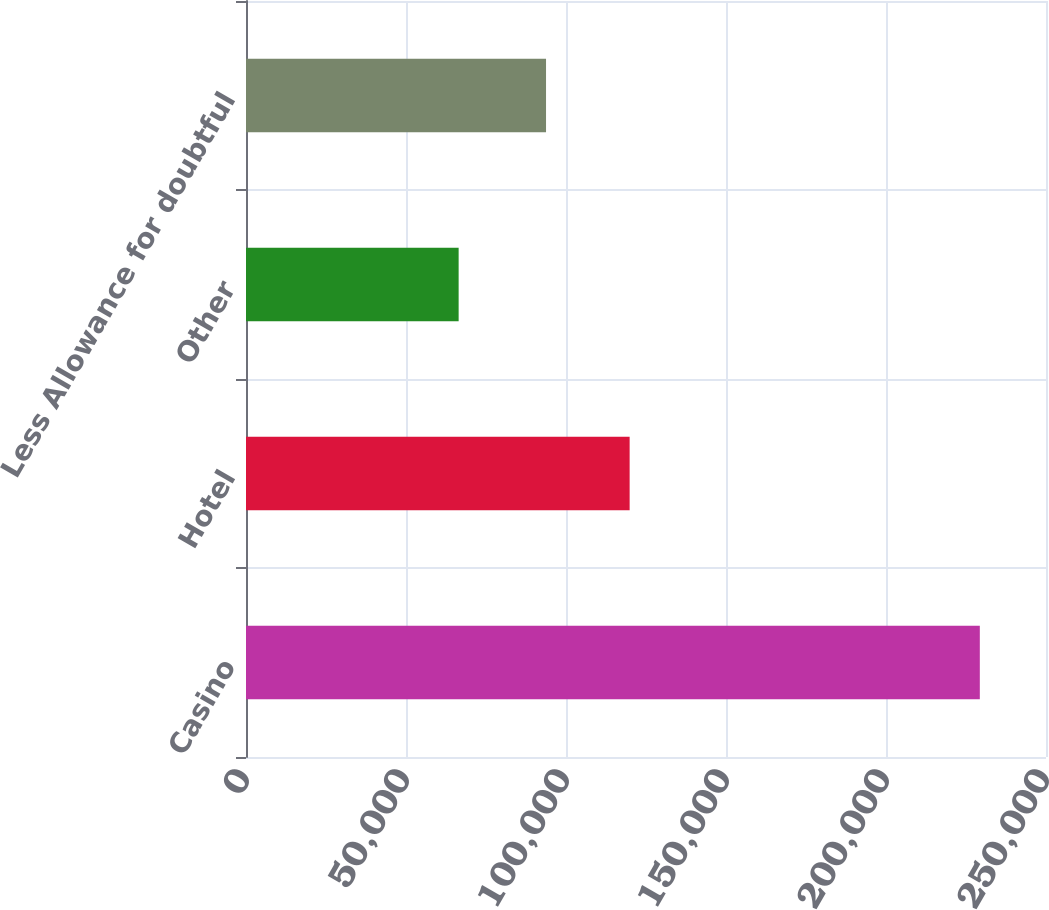<chart> <loc_0><loc_0><loc_500><loc_500><bar_chart><fcel>Casino<fcel>Hotel<fcel>Other<fcel>Less Allowance for doubtful<nl><fcel>229318<fcel>119887<fcel>66449<fcel>93760<nl></chart> 